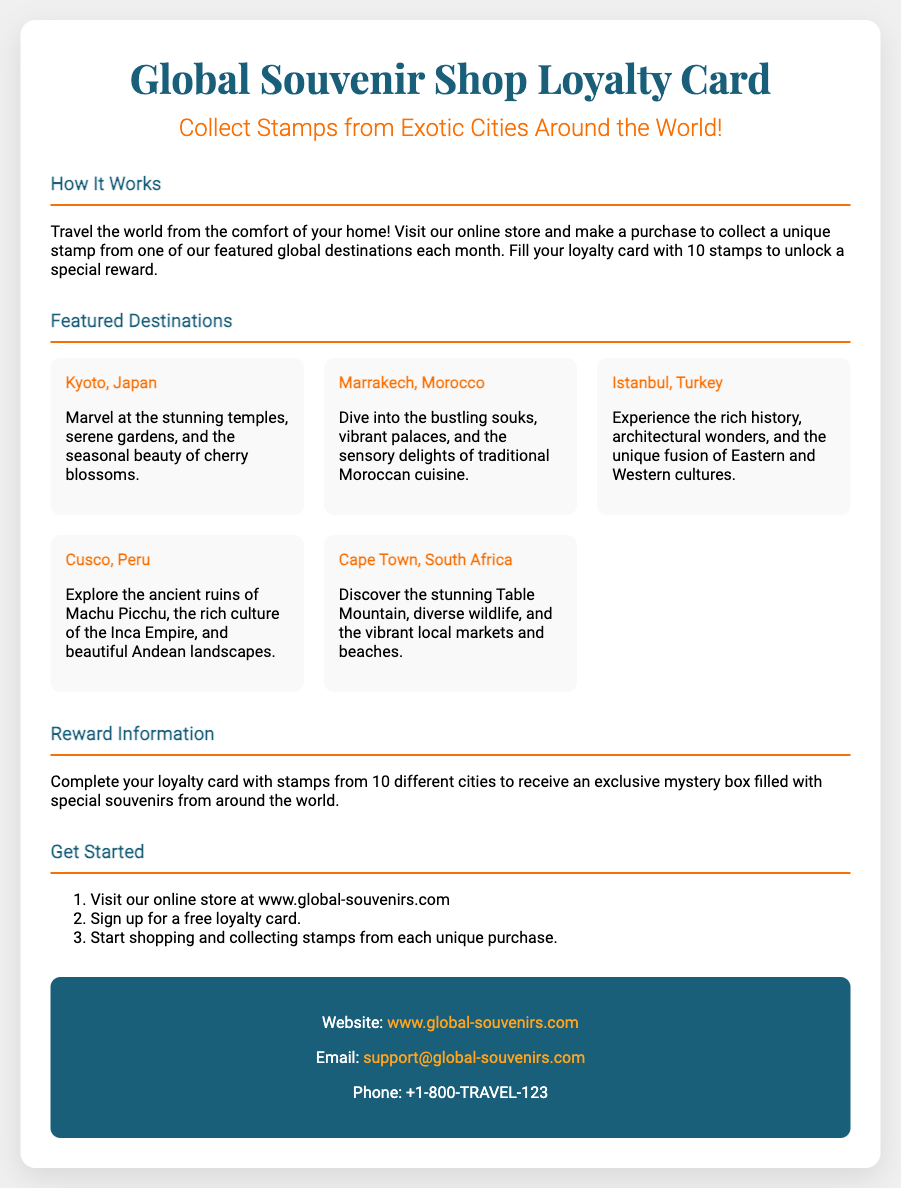What is the title of the loyalty card? The title is prominently displayed at the top of the card, indicating the focus of the document.
Answer: Global Souvenir Shop Loyalty Card How many stamps are needed to unlock the special reward? The document specifies the requirement for completing the loyalty card to receive a reward.
Answer: 10 stamps What kind of reward do participants receive? The document describes the nature of the reward for completing the loyalty card, emphasizing the excitement of the offer.
Answer: exclusive mystery box Name one featured destination mentioned in the document. The document lists several destinations, making it easy to identify one.
Answer: Kyoto, Japan What should you do to start collecting stamps? The document provides steps on how to participate in the loyalty program, outlining the initial action required.
Answer: Visit online store Why is the card design appealing for travelers? This question requires reasoning about the target audience and how the design engages them.
Answer: It showcases exotic global destinations 